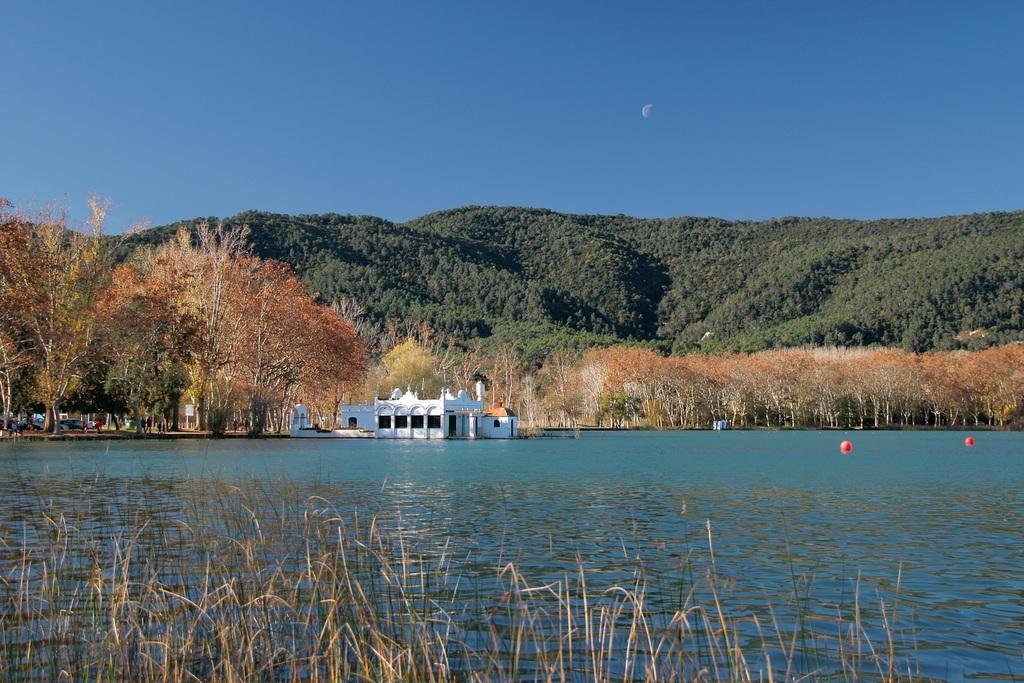What type of vegetation is present in the image? There is grass in the image. What can be seen in the background of the image? There is a water surface, a house, trees, a mountain, and the sky visible in the background of the image. What type of bun is being traded in the image? There is no bun or trade activity present in the image. 